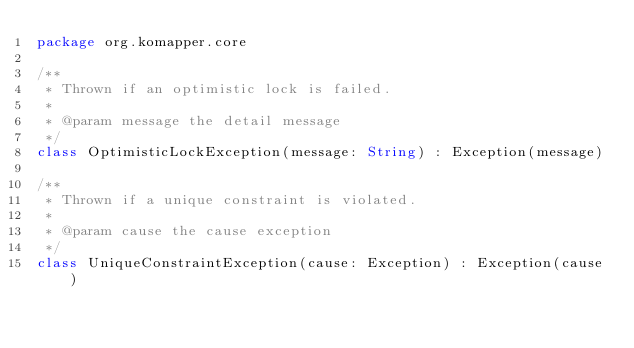Convert code to text. <code><loc_0><loc_0><loc_500><loc_500><_Kotlin_>package org.komapper.core

/**
 * Thrown if an optimistic lock is failed.
 *
 * @param message the detail message
 */
class OptimisticLockException(message: String) : Exception(message)

/**
 * Thrown if a unique constraint is violated.
 *
 * @param cause the cause exception
 */
class UniqueConstraintException(cause: Exception) : Exception(cause)
</code> 